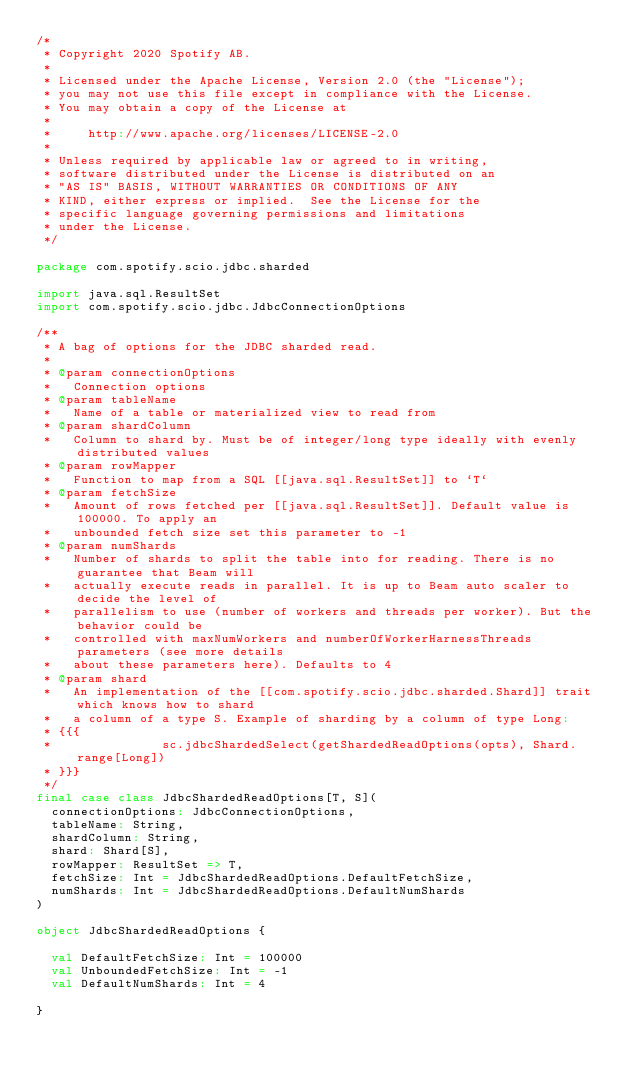<code> <loc_0><loc_0><loc_500><loc_500><_Scala_>/*
 * Copyright 2020 Spotify AB.
 *
 * Licensed under the Apache License, Version 2.0 (the "License");
 * you may not use this file except in compliance with the License.
 * You may obtain a copy of the License at
 *
 *     http://www.apache.org/licenses/LICENSE-2.0
 *
 * Unless required by applicable law or agreed to in writing,
 * software distributed under the License is distributed on an
 * "AS IS" BASIS, WITHOUT WARRANTIES OR CONDITIONS OF ANY
 * KIND, either express or implied.  See the License for the
 * specific language governing permissions and limitations
 * under the License.
 */

package com.spotify.scio.jdbc.sharded

import java.sql.ResultSet
import com.spotify.scio.jdbc.JdbcConnectionOptions

/**
 * A bag of options for the JDBC sharded read.
 *
 * @param connectionOptions
 *   Connection options
 * @param tableName
 *   Name of a table or materialized view to read from
 * @param shardColumn
 *   Column to shard by. Must be of integer/long type ideally with evenly distributed values
 * @param rowMapper
 *   Function to map from a SQL [[java.sql.ResultSet]] to `T`
 * @param fetchSize
 *   Amount of rows fetched per [[java.sql.ResultSet]]. Default value is 100000. To apply an
 *   unbounded fetch size set this parameter to -1
 * @param numShards
 *   Number of shards to split the table into for reading. There is no guarantee that Beam will
 *   actually execute reads in parallel. It is up to Beam auto scaler to decide the level of
 *   parallelism to use (number of workers and threads per worker). But the behavior could be
 *   controlled with maxNumWorkers and numberOfWorkerHarnessThreads parameters (see more details
 *   about these parameters here). Defaults to 4
 * @param shard
 *   An implementation of the [[com.spotify.scio.jdbc.sharded.Shard]] trait which knows how to shard
 *   a column of a type S. Example of sharding by a column of type Long:
 * {{{
 *               sc.jdbcShardedSelect(getShardedReadOptions(opts), Shard.range[Long])
 * }}}
 */
final case class JdbcShardedReadOptions[T, S](
  connectionOptions: JdbcConnectionOptions,
  tableName: String,
  shardColumn: String,
  shard: Shard[S],
  rowMapper: ResultSet => T,
  fetchSize: Int = JdbcShardedReadOptions.DefaultFetchSize,
  numShards: Int = JdbcShardedReadOptions.DefaultNumShards
)

object JdbcShardedReadOptions {

  val DefaultFetchSize: Int = 100000
  val UnboundedFetchSize: Int = -1
  val DefaultNumShards: Int = 4

}
</code> 